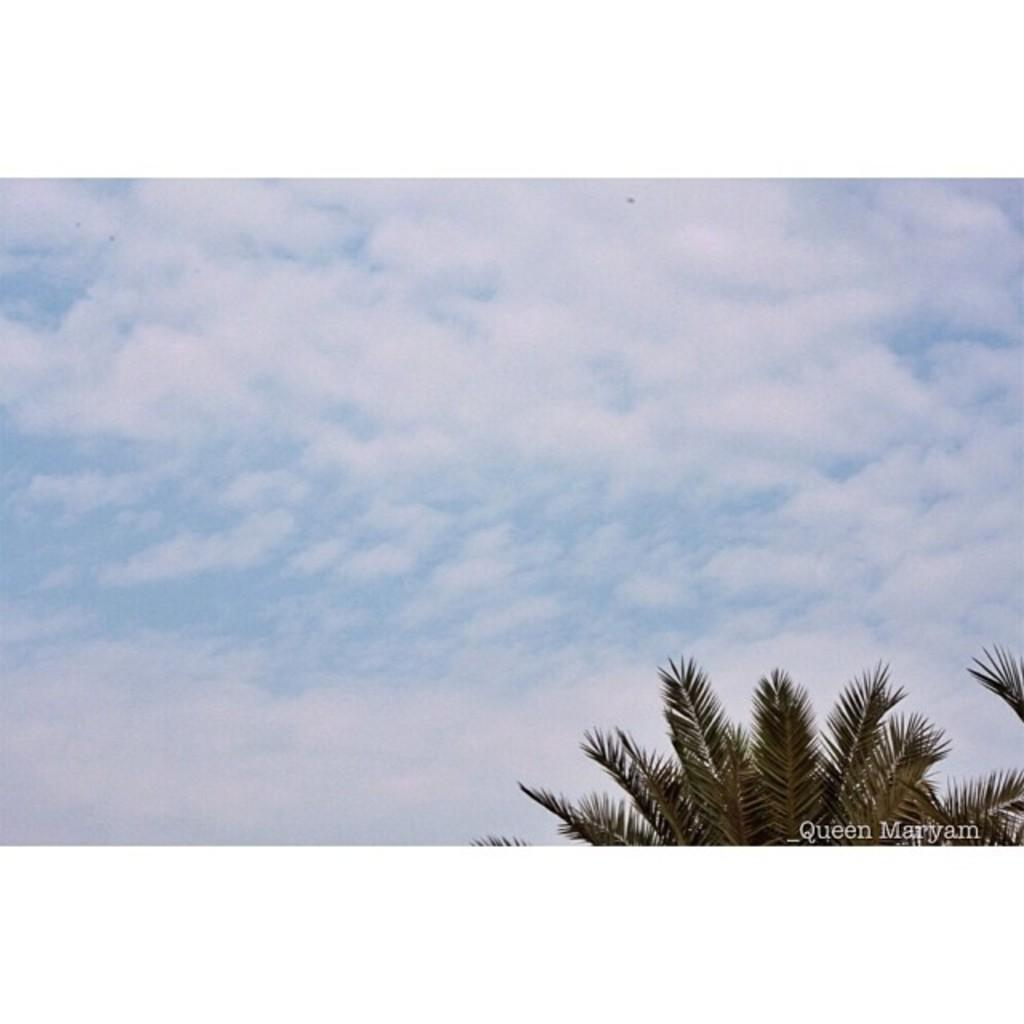What type of vegetation can be seen in the image? There are trees in the image. What can be seen in the sky in the image? There are clouds in the sky in the image. What color is the baby's hair in the image? There is no baby or hair present in the image; it only features trees and clouds. How is the string used in the image? There is no string present in the image. 